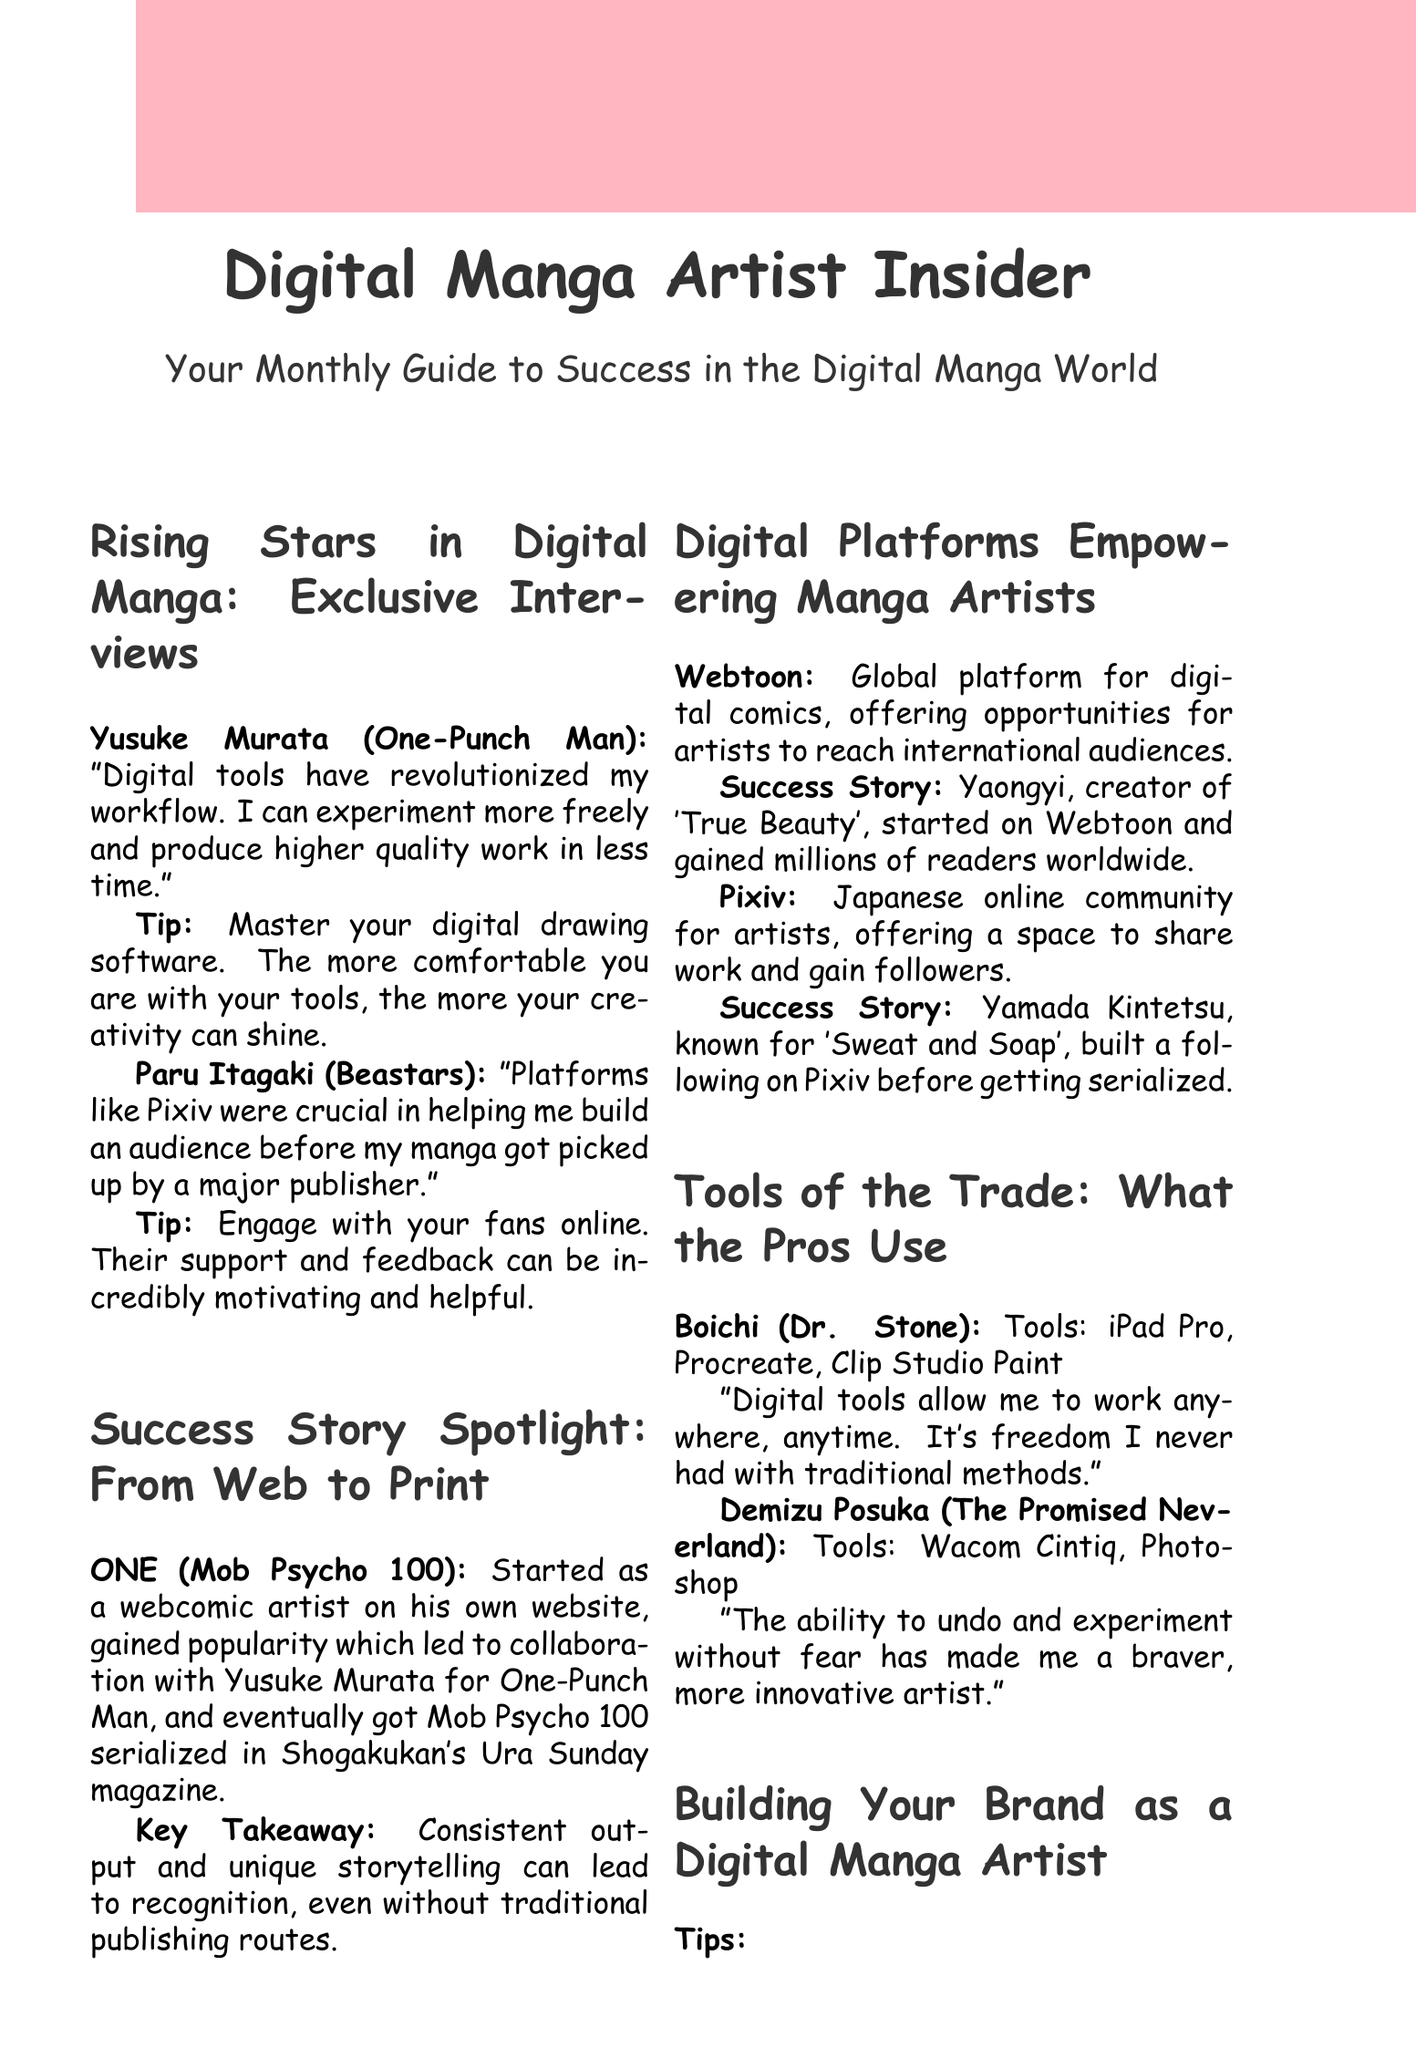What is Yusuke Murata known for? Yusuke Murata is known for creating "One-Punch Man," which is mentioned in the interview section of the newsletter.
Answer: One-Punch Man What digital platform did Yaongyi use to gain readers? The newsletter states that Yaongyi, the creator of "True Beauty," started on Webtoon to reach millions of readers.
Answer: Webtoon What is one tool used by Boichi? According to the document, Boichi uses the iPad Pro, which is listed in the tools section for professionals.
Answer: iPad Pro What key takeaway is mentioned in ONE's success story? The key takeaway highlights the importance of consistent output and unique storytelling in gaining recognition.
Answer: Consistent output and unique storytelling How many main tips are provided for building a brand? The document lists five main tips for building a brand as a digital manga artist in the relevant section.
Answer: Five 